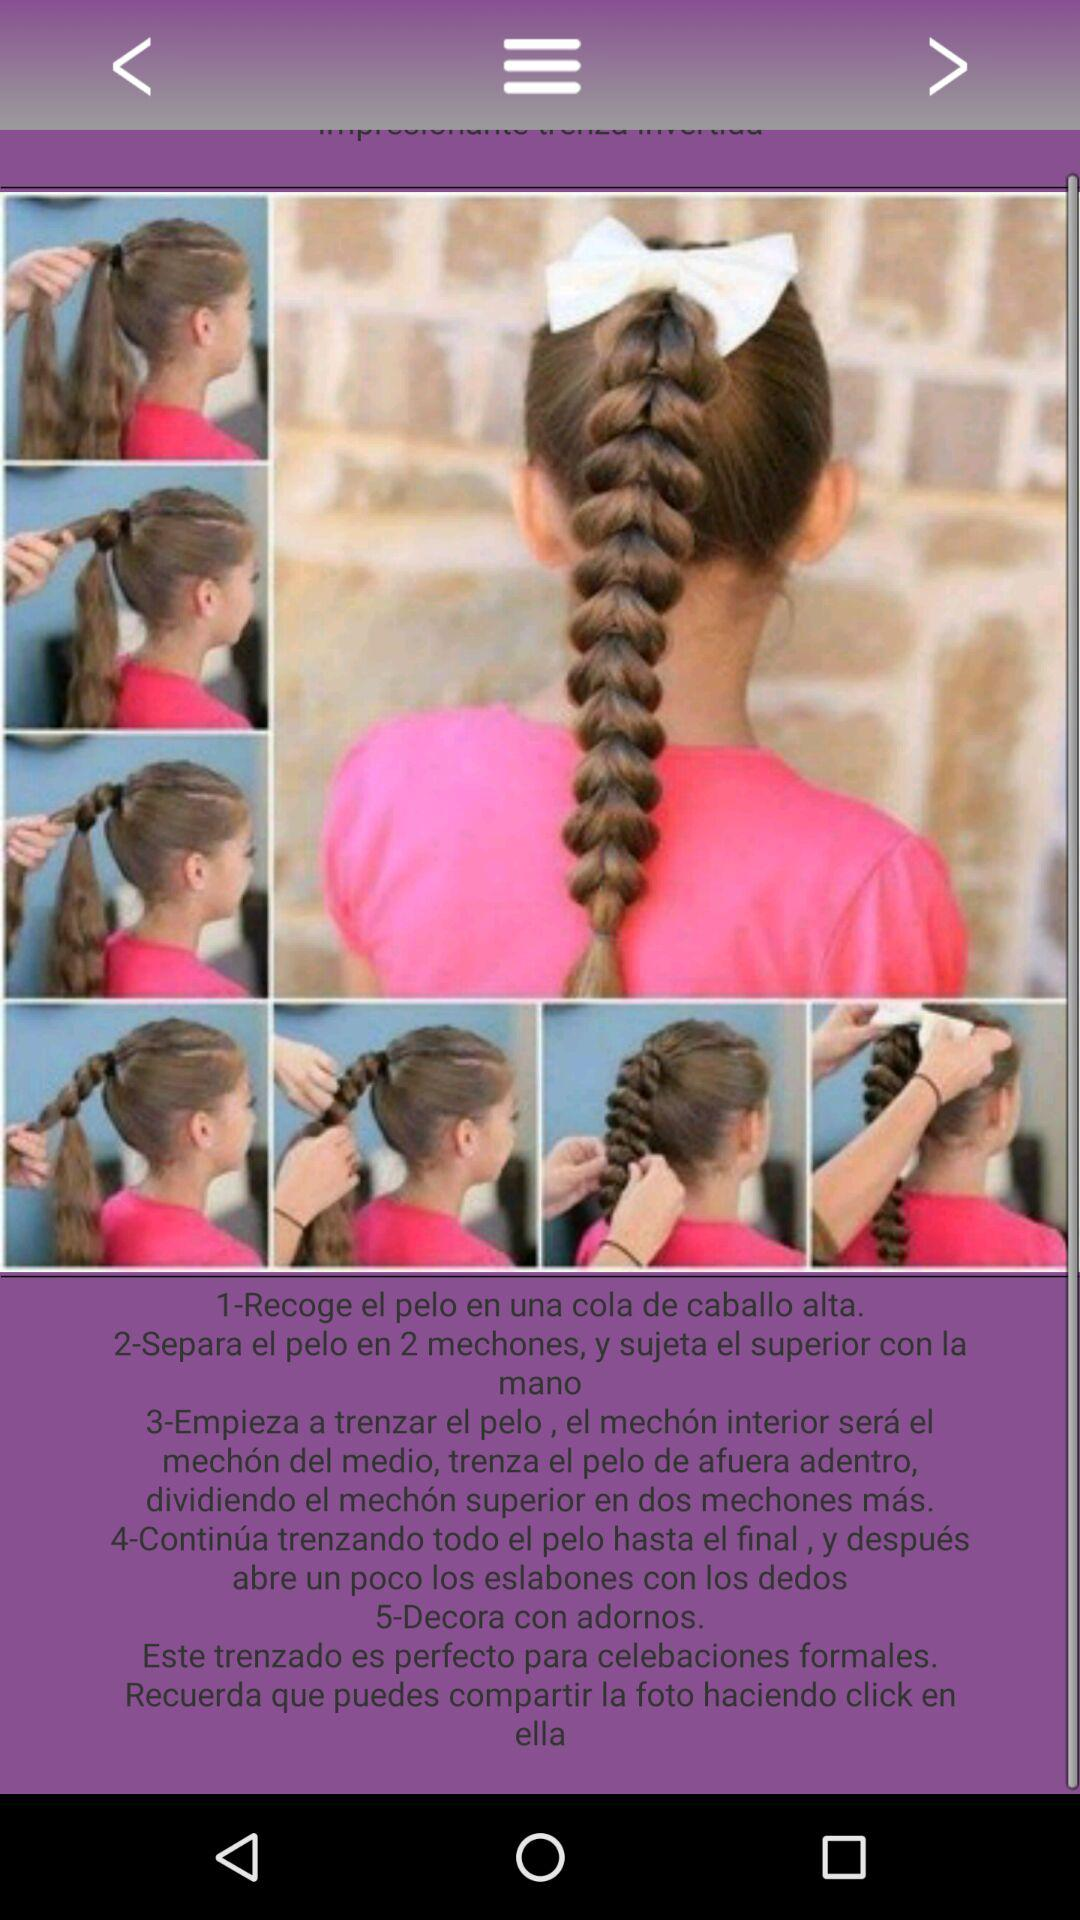How many steps are there in the tutorial?
Answer the question using a single word or phrase. 5 